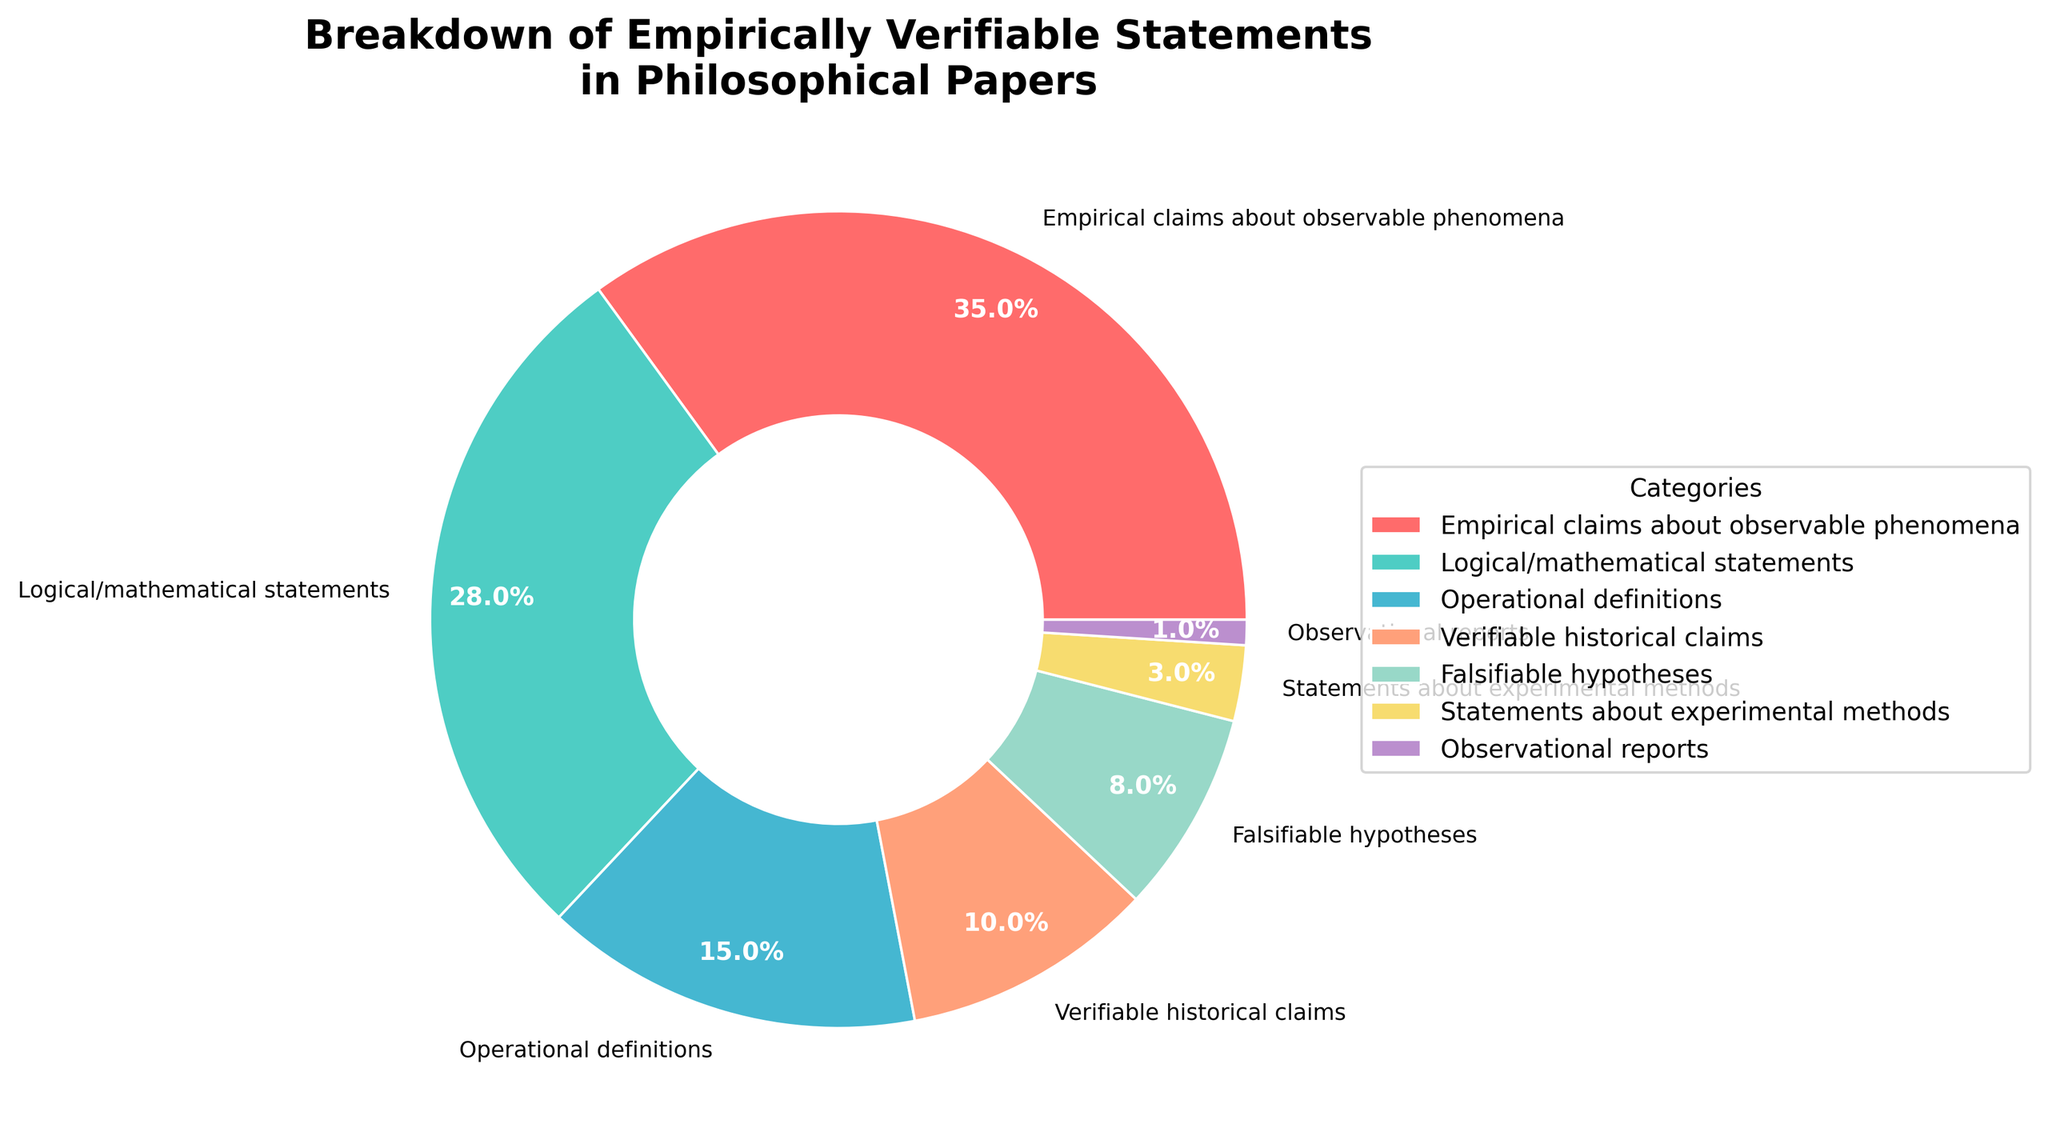What is the largest category in the chart? The largest category is identified by the highest percentage in the pie chart, which represents 35%. This category is "Empirical claims about observable phenomena" as shown by the label.
Answer: Empirical claims about observable phenomena What is the sum of the percentages for Logical/mathematical statements and Operational definitions? To find the sum, add the percentages of both categories: Logical/mathematical statements (28%) + Operational definitions (15%) = 43%.
Answer: 43% Which category has the smallest representation in the pie chart? The smallest category is the one with the lowest percentage in the chart. Observational reports have the smallest representation with 1%.
Answer: Observational reports How much larger is the percentage of Empirical claims about observable phenomena compared to Statements about experimental methods? Calculate the difference between the two percentages: Empirical claims about observable phenomena (35%) - Statements about experimental methods (3%) = 32%.
Answer: 32% What percentage of categories make up more than 10% of the chart? The categories more than 10% are: Empirical claims about observable phenomena (35%), Logical/mathematical statements (28%), and Operational definitions (15%). There are three such categories out of a total of seven. (3/7) ≈ 42.9%.
Answer: 42.9% If you combine Verifiable historical claims and Falsifiable hypotheses, what will be their total percentage in the chart? Add the percentages of both categories: Verifiable historical claims (10%) + Falsifiable hypotheses (8%) = 18%.
Answer: 18% Identify the category represented by the yellow color. By referring to the legend and correlating it with the wedge colors in the pie chart, yellow corresponds to "Statements about experimental methods."
Answer: Statements about experimental methods Order the categories by decreasing percentage. The order from highest to lowest percentage is: Empirical claims about observable phenomena (35%), Logical/mathematical statements (28%), Operational definitions (15%), Verifiable historical claims (10%), Falsifiable hypotheses (8%), Statements about experimental methods (3%), Observational reports (1%).
Answer: Empirical claims about observable phenomena, Logical/mathematical statements, Operational definitions, Verifiable historical claims, Falsifiable hypotheses, Statements about experimental methods, Observational reports Which categories combined make up exactly 50% of the chart? Adding the percentages of the two largest categories: Empirical claims about observable phenomena (35%) + Logical/mathematical statements (28%), yields 63%, which is more than 50%. Next, we consider the next larger category: Empirical claims about observable phenomena (35%) + Operational definitions (15%) = 50%. Thus, these are the two categories.
Answer: Empirical claims about observable phenomena and Operational definitions What portion of the chart is made up by categories with representation less than 10%? Add the percentages for categories with less than 10%, which include: Verifiable historical claims (10%), Falsifiable hypotheses (8%), Statements about experimental methods (3%), and Observational reports (1%): 10% + 8% + 3% + 1% = 22%.
Answer: 22% 